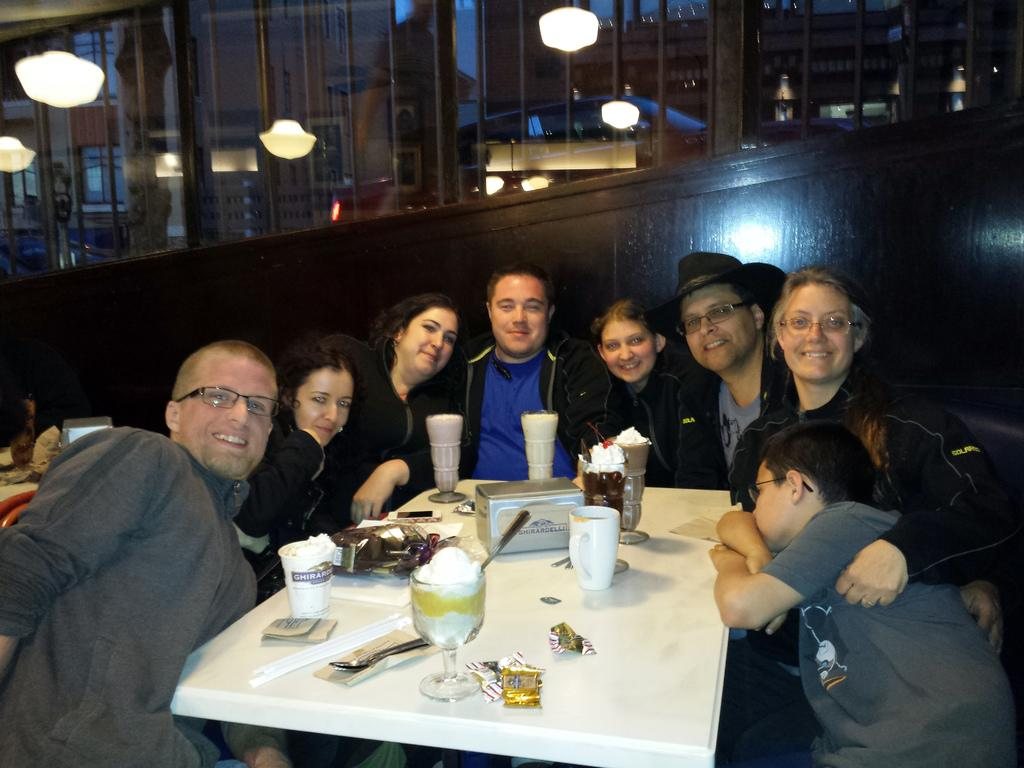How many people are in the image? There is a group of people in the image, but the exact number is not specified. What are the people doing in the image? The people are sitting in chairs in the image. What is in front of the group of people? There is a white table in front of the group. What can be found on the table? There are eatables on the table. What type of button is being used to support the table in the image? There is no button present in the image, and the table is not being supported by any visible means in the image. 